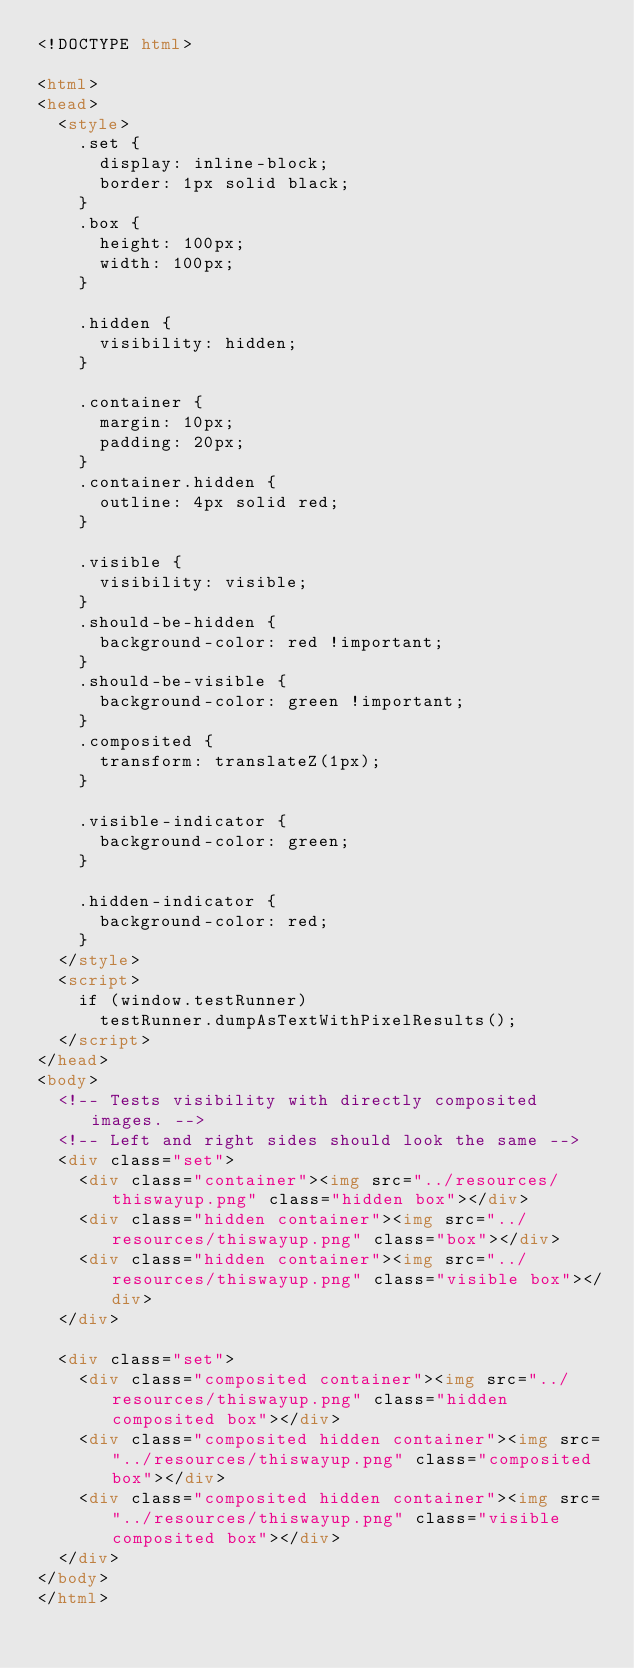Convert code to text. <code><loc_0><loc_0><loc_500><loc_500><_HTML_><!DOCTYPE html>

<html>
<head>
  <style>
    .set {
      display: inline-block;
      border: 1px solid black;
    }
    .box {
      height: 100px;
      width: 100px;
    }
    
    .hidden {
      visibility: hidden;
    }
    
    .container {
      margin: 10px;
      padding: 20px;
    }
    .container.hidden {
      outline: 4px solid red;
    }
    
    .visible {
      visibility: visible;
    }
    .should-be-hidden {
      background-color: red !important;
    }
    .should-be-visible {
      background-color: green !important;
    }
    .composited {
      transform: translateZ(1px);
    }
    
    .visible-indicator {
      background-color: green;
    }

    .hidden-indicator {
      background-color: red;
    }
  </style>
  <script>
    if (window.testRunner)
      testRunner.dumpAsTextWithPixelResults();
  </script>
</head>
<body>
  <!-- Tests visibility with directly composited images. -->
  <!-- Left and right sides should look the same -->
  <div class="set">
    <div class="container"><img src="../resources/thiswayup.png" class="hidden box"></div>
    <div class="hidden container"><img src="../resources/thiswayup.png" class="box"></div>
    <div class="hidden container"><img src="../resources/thiswayup.png" class="visible box"></div>
  </div>

  <div class="set">
    <div class="composited container"><img src="../resources/thiswayup.png" class="hidden composited box"></div>
    <div class="composited hidden container"><img src="../resources/thiswayup.png" class="composited box"></div>
    <div class="composited hidden container"><img src="../resources/thiswayup.png" class="visible composited box"></div>
  </div>
</body>
</html>
</code> 